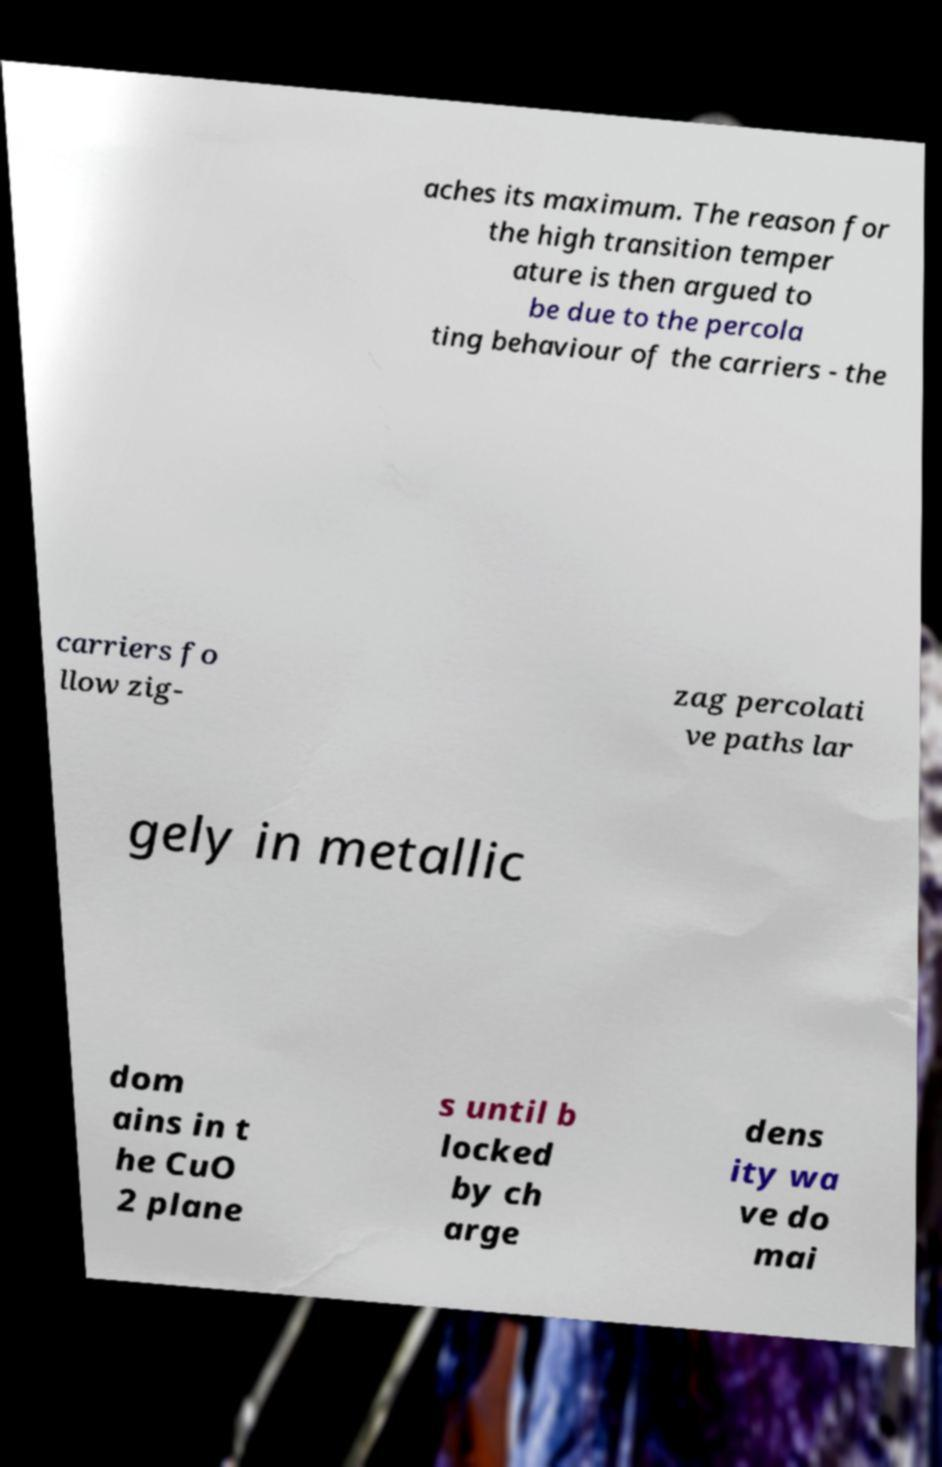For documentation purposes, I need the text within this image transcribed. Could you provide that? aches its maximum. The reason for the high transition temper ature is then argued to be due to the percola ting behaviour of the carriers - the carriers fo llow zig- zag percolati ve paths lar gely in metallic dom ains in t he CuO 2 plane s until b locked by ch arge dens ity wa ve do mai 